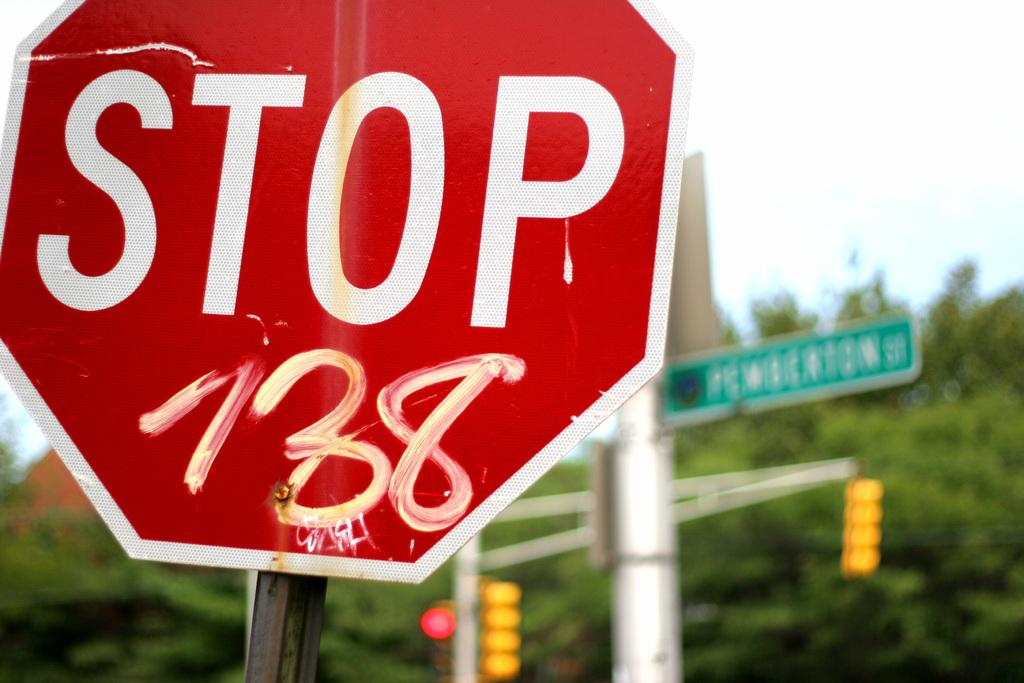<image>
Write a terse but informative summary of the picture. The stop sign shown has some which graffiti paint on it. 